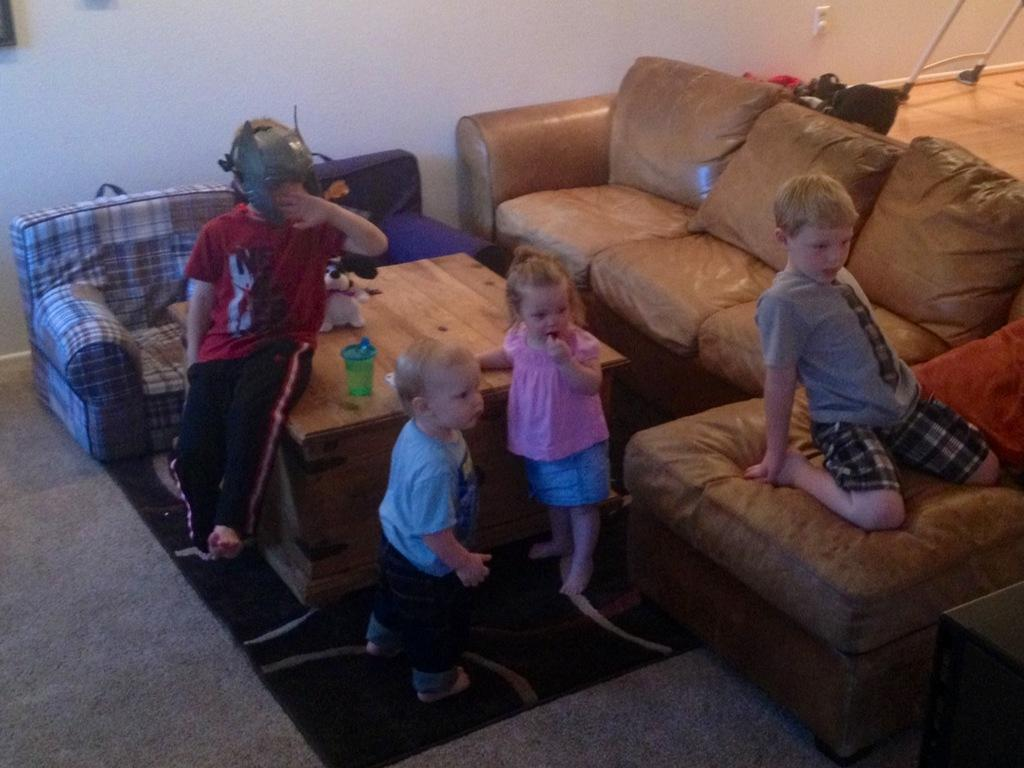How many children are present in the image? There are four children in the image. Where are the children playing? The children are playing in a living room. What are two children doing at the table? Two children are standing at a table. What is the position of the third child in the image? One child is sitting on the table. What is the position of the fourth child in the image? One child is sitting on a sofa. What type of pies are the children eating in the image? There are no pies present in the image; the children are playing in a living room. 